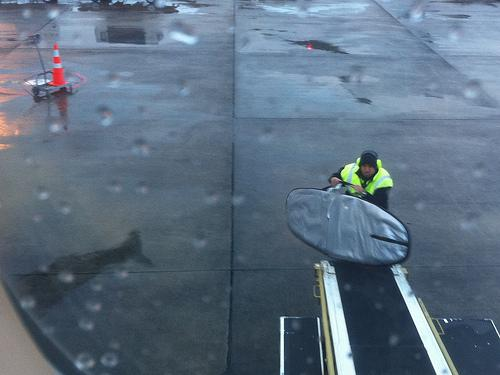What is the main occupation of the person in the image? An airport employee lifting a silver bag. Identify the color and pattern on the traffic cone. The traffic cone is orange with gray reflective stripes. Detail the attire of the airport worker. The airport worker is clad in a yellow fluorescent safety vest, a black coat, and a dark knit cap. Determine the weather conditions that may have caused the scene in the image. It has likely rained recently or is still raining, causing the pavement to be wet and puddles to form. What is the condition of the pavement in the image? The pavement is wet, and it appears to be a dark color. Provide a brief description of the bag being lifted. It is a long, oval, silver bag with a strap. Count the number of visible puddles in the picture. Two puddles can be seen on the wet black pavement. Enumerate the types of headwear and their corresponding colors on the person. The person is wearing a black knit cap and earmuffs. Examine and describe the core scene the image is portraying. A man working at an airport is loading luggage onto a conveyor belt, while surrounded by puddles on a wet pavement. Please list the noticeable pieces of equipment on the ground. A black airport conveyor belt, an orange traffic cone, and a hand cart holding another cone. What color is the reflective stripe on the employee's safety vest? Yellow Describe the color and stripe pattern on the orange traffic cone. The traffic cone is orange with white reflective stripes. Describe the conditions of the ground in the image. Wet black pavement with puddles Identify the red object reflected in the puddle. Red light What is the color of the safety vest worn by the airport employee? Fluorescent yellow What color is the pavement in the image? Black Is there a traffic cone in the image? If so, describe its appearance. Yes, there is an orange traffic cone with reflective stripes. Which of these is an accurate description of the cone in the image? (a) green cone with stripes (b) orange cone with reflective stripes (c) blue cone with stripes (b) orange cone with reflective stripes Identify the type of hat worn by the airport worker. Dark knit cap Is the airport conveyor belt white in color? The airport conveyor belt is black, not white. What details can you notice in the grey bag that the airport worker is holding? A strap on the grey bag. What type of area is the scene taking place in? Dark wet paved area Is the man wearing a blue coat while lifting the silver bag? The man is actually wearing a black coat, not a blue one. What type of job does the person in the image likely have? Airport employee What is the worker lifting in the image? A silver bag Is there a conveyor belt in the image? Describe its appearance if present. Yes, there is a black airport conveyor belt. Can you see the airport employee taking off his knit cap? The airport employee is wearing a dark knit cap, but there's no indication of him taking it off. Write a short description of the scene in the image. Airport employee lifting a silver bag near a wet black pavement with puddles and an orange traffic cone in the foreground. Is there a person loading luggage in this image? What is the color of their coat? Yes, a male worker wearing a black coat is loading luggage. Does the puddle have blue light reflecting in it? The puddle has a red light reflected in it, not a blue one. What does the airport worker wear on their head to keep warm? A black knit hat What type of object is situated on a hand cart? Traffic cone Is there a green traffic cone on the wet pavement? The traffic cone in the image is orange and white, not green. Describe the emotional expression of the person in the image. The image does not show the person's facial expression clearly. Is there a large circle in the bottom-right corner of the image? There are small circles mentioned in various positions, but no mention of a large circle in the bottom-right corner. Can you see any earmuffs on the person in the image? What color are they? Yes, the earmuffs are black. 